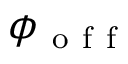<formula> <loc_0><loc_0><loc_500><loc_500>\phi _ { o f f }</formula> 